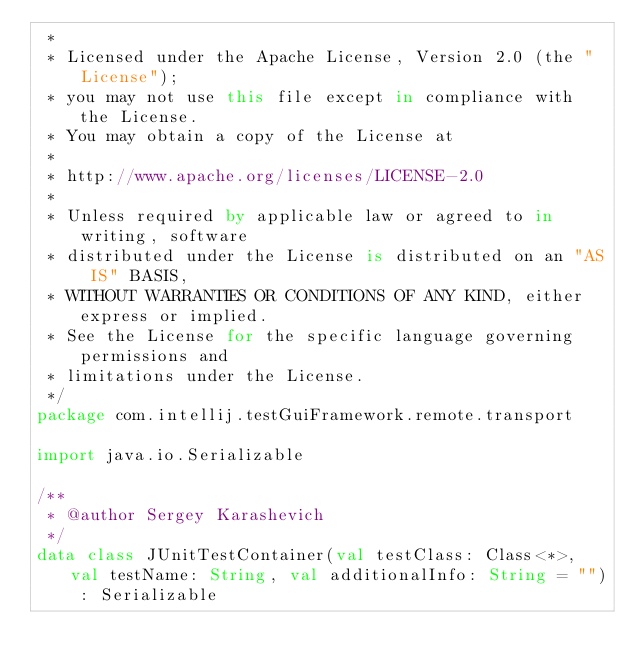<code> <loc_0><loc_0><loc_500><loc_500><_Kotlin_> *
 * Licensed under the Apache License, Version 2.0 (the "License");
 * you may not use this file except in compliance with the License.
 * You may obtain a copy of the License at
 *
 * http://www.apache.org/licenses/LICENSE-2.0
 *
 * Unless required by applicable law or agreed to in writing, software
 * distributed under the License is distributed on an "AS IS" BASIS,
 * WITHOUT WARRANTIES OR CONDITIONS OF ANY KIND, either express or implied.
 * See the License for the specific language governing permissions and
 * limitations under the License.
 */
package com.intellij.testGuiFramework.remote.transport

import java.io.Serializable

/**
 * @author Sergey Karashevich
 */
data class JUnitTestContainer(val testClass: Class<*>, val testName: String, val additionalInfo: String = "") : Serializable</code> 